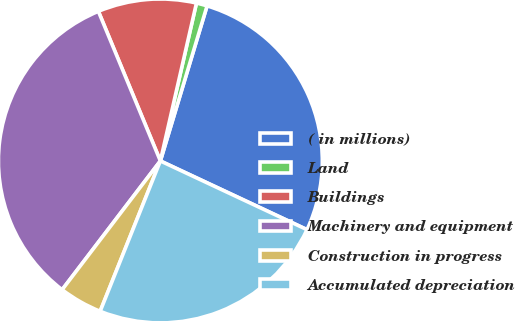<chart> <loc_0><loc_0><loc_500><loc_500><pie_chart><fcel>( in millions)<fcel>Land<fcel>Buildings<fcel>Machinery and equipment<fcel>Construction in progress<fcel>Accumulated depreciation<nl><fcel>27.32%<fcel>1.08%<fcel>9.83%<fcel>33.38%<fcel>4.31%<fcel>24.09%<nl></chart> 